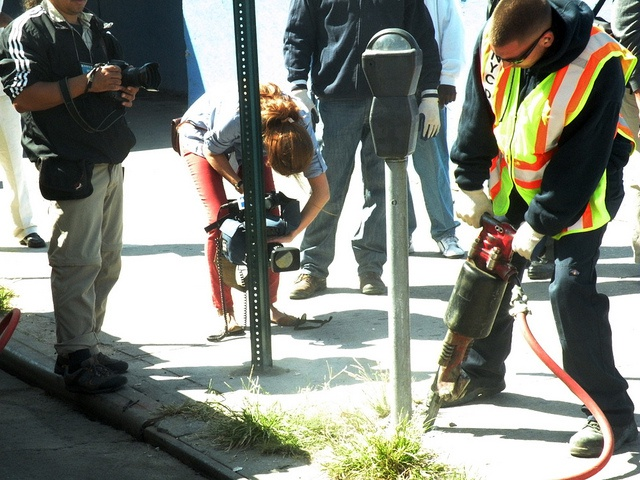Describe the objects in this image and their specific colors. I can see people in lightblue, black, ivory, gray, and khaki tones, people in lightblue, black, gray, and maroon tones, people in lightblue, black, white, gray, and maroon tones, people in lightblue, black, gray, purple, and white tones, and people in lightblue and teal tones in this image. 